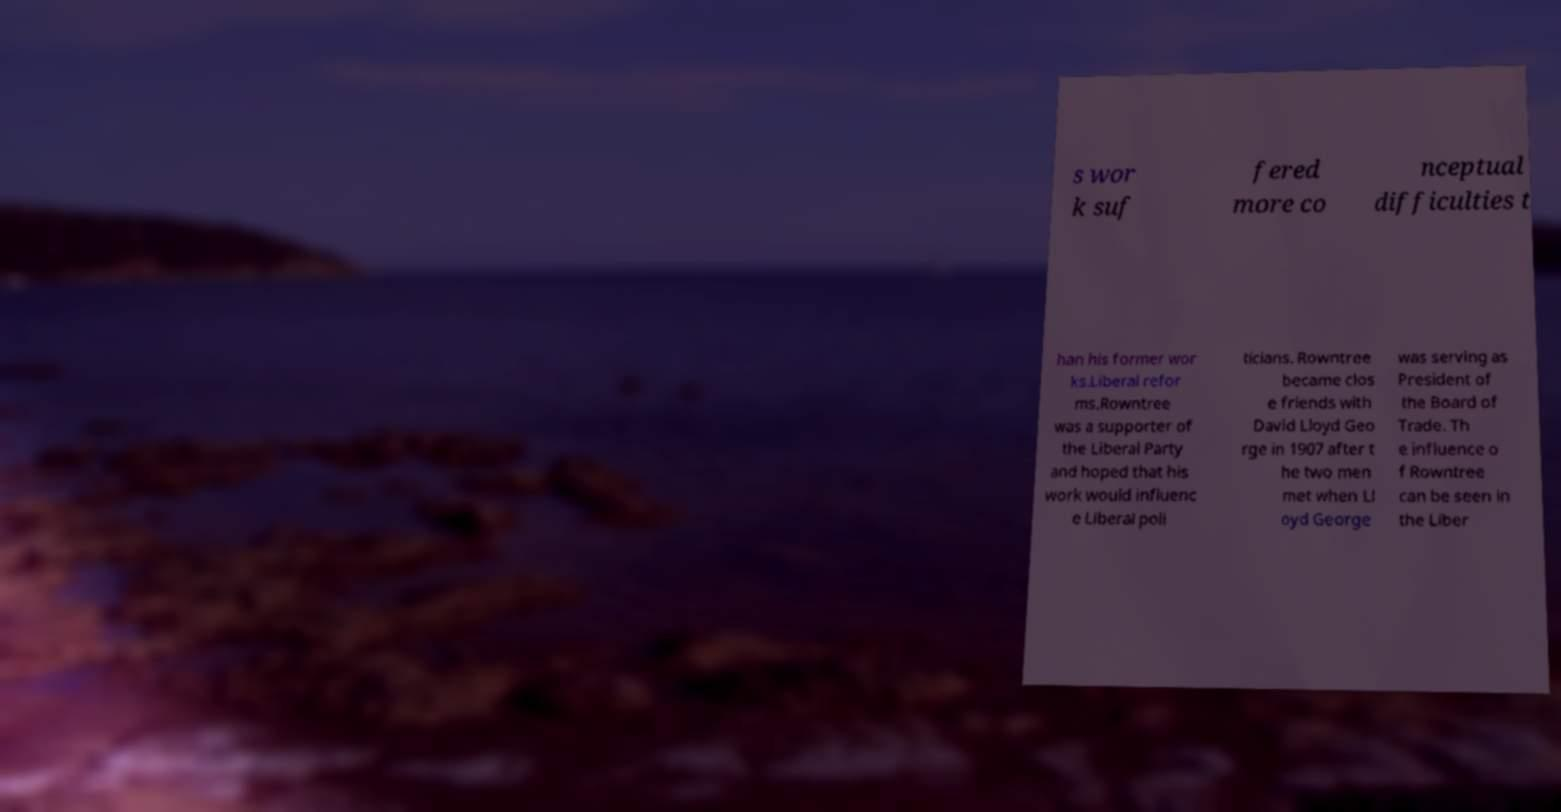What messages or text are displayed in this image? I need them in a readable, typed format. s wor k suf fered more co nceptual difficulties t han his former wor ks.Liberal refor ms.Rowntree was a supporter of the Liberal Party and hoped that his work would influenc e Liberal poli ticians. Rowntree became clos e friends with David Lloyd Geo rge in 1907 after t he two men met when Ll oyd George was serving as President of the Board of Trade. Th e influence o f Rowntree can be seen in the Liber 